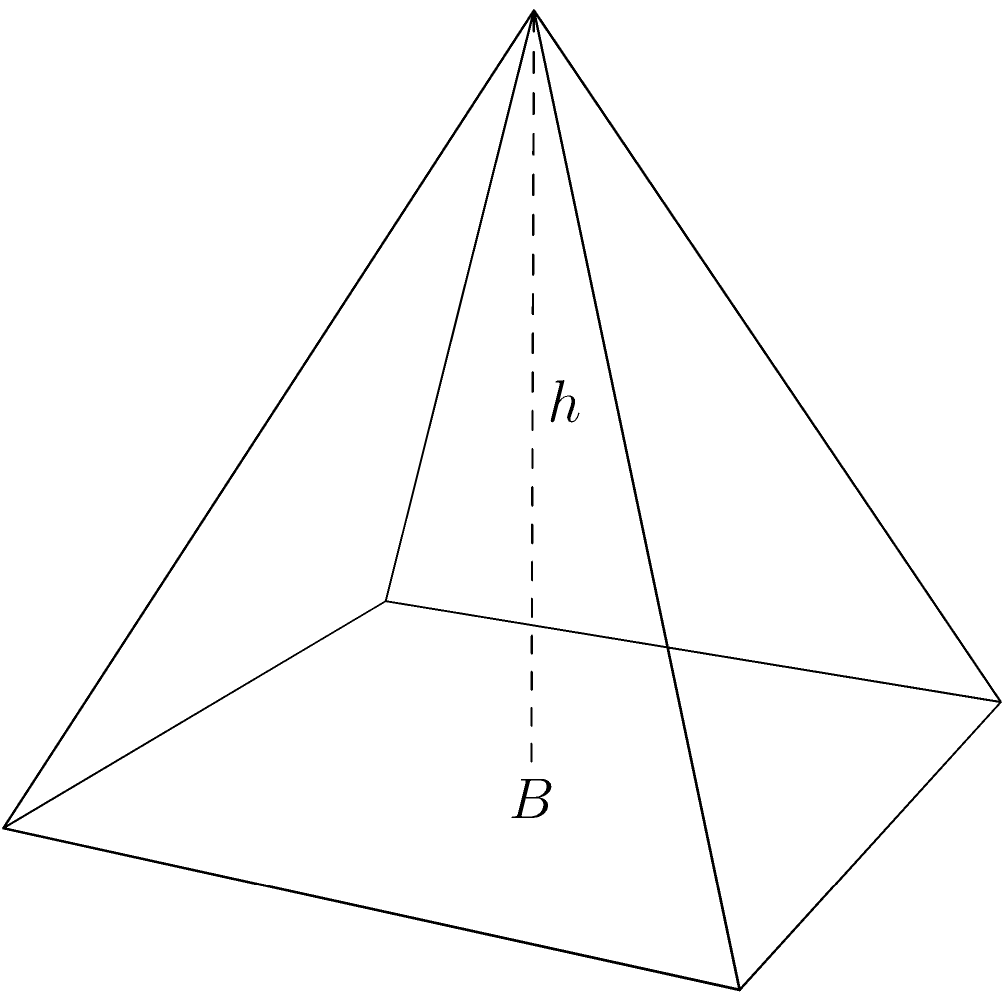In your quest to bring history to life, you've decided to create a scale model of the Great Pyramid of Giza for your classroom. The base of your model pyramid has an area of 144 cm² and its height is 15 cm. Calculate the volume of your model pyramid. Let's approach this step-by-step:

1) The formula for the volume of a pyramid is:

   $$V = \frac{1}{3} \times B \times h$$

   Where $V$ is the volume, $B$ is the area of the base, and $h$ is the height.

2) We are given:
   - Base area (B) = 144 cm²
   - Height (h) = 15 cm

3) Let's substitute these values into our formula:

   $$V = \frac{1}{3} \times 144 \text{ cm}² \times 15 \text{ cm}$$

4) Now we can calculate:

   $$V = \frac{1}{3} \times 2160 \text{ cm}³$$
   $$V = 720 \text{ cm}³$$

Thus, the volume of your model pyramid is 720 cubic centimeters.
Answer: 720 cm³ 